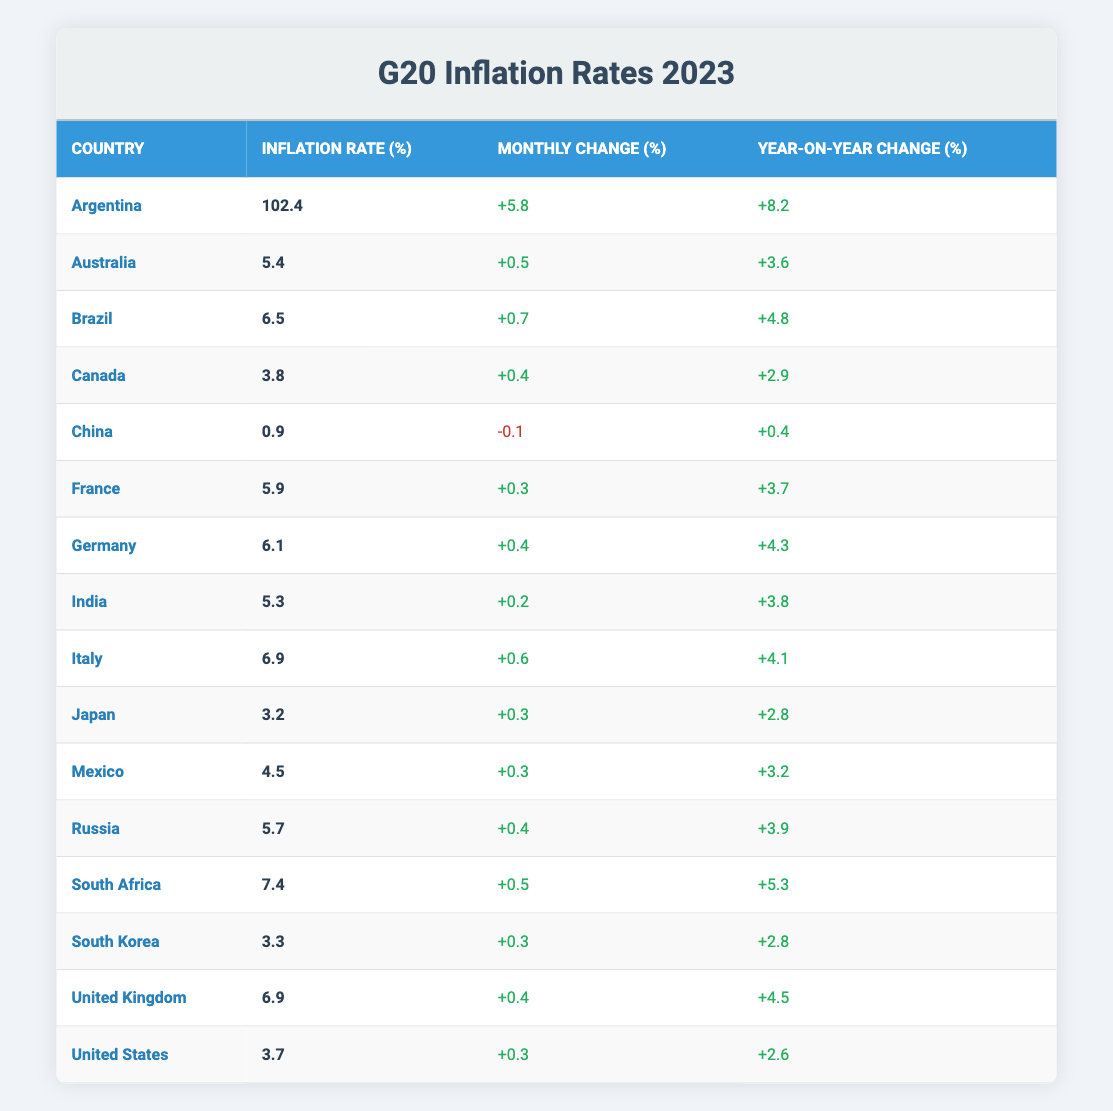What is the inflation rate for Argentina? The table shows that the inflation rate for Argentina is listed directly as 102.4%.
Answer: 102.4% Which country has the lowest inflation rate in 2023? Referring to the values in the inflation rate column, China has the lowest inflation rate at 0.9%.
Answer: China What is the monthly change in inflation rate for Brazil? The table indicates that Brazil's monthly change in inflation rate is 0.7%.
Answer: 0.7% Is the year-on-year change for South Africa greater than that for Canada? South Africa's year-on-year change is 5.3%, while Canada's is 2.9%. Since 5.3% is greater than 2.9%, this statement is true.
Answer: Yes What is the average inflation rate for the G20 countries? To calculate the average, sum all inflation rates: (102.4 + 5.4 + 6.5 + 3.8 + 0.9 + 5.9 + 6.1 + 5.3 + 6.9 + 3.2 + 4.5 + 5.7 + 7.4 + 3.3 + 6.9 + 3.7)/16 = 15.16, then divide by 16 which equals 6.52%.
Answer: 6.52% Which country showed a negative monthly change in inflation? Looking through the monthly change column, China is the only country with a negative change of -0.1%.
Answer: China What is the difference in year-on-year change between Argentina and Australia? The year-on-year change for Argentina is 8.2%, and for Australia, it is 3.6%. The difference is 8.2% - 3.6% = 4.6%.
Answer: 4.6% Does India have a higher inflation rate than Japan? India's inflation rate is 5.3%, while Japan's is 3.2%. Since 5.3% is greater than 3.2%, the statement is true.
Answer: Yes Which countries have an inflation rate above 5%? By reviewing the table, Argentina (102.4%), Brazil (6.5%), Italy (6.9%), South Africa (7.4%), United Kingdom (6.9%), and Germany (6.1%) all have inflation rates above 5%.
Answer: Argentina, Brazil, Italy, South Africa, United Kingdom, Germany 